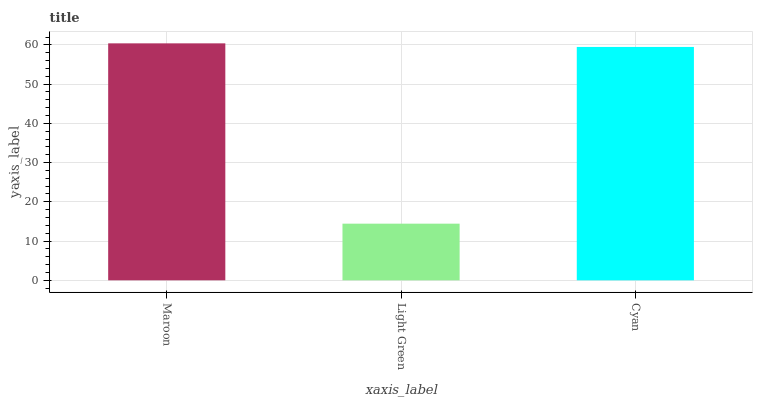Is Light Green the minimum?
Answer yes or no. Yes. Is Maroon the maximum?
Answer yes or no. Yes. Is Cyan the minimum?
Answer yes or no. No. Is Cyan the maximum?
Answer yes or no. No. Is Cyan greater than Light Green?
Answer yes or no. Yes. Is Light Green less than Cyan?
Answer yes or no. Yes. Is Light Green greater than Cyan?
Answer yes or no. No. Is Cyan less than Light Green?
Answer yes or no. No. Is Cyan the high median?
Answer yes or no. Yes. Is Cyan the low median?
Answer yes or no. Yes. Is Light Green the high median?
Answer yes or no. No. Is Maroon the low median?
Answer yes or no. No. 